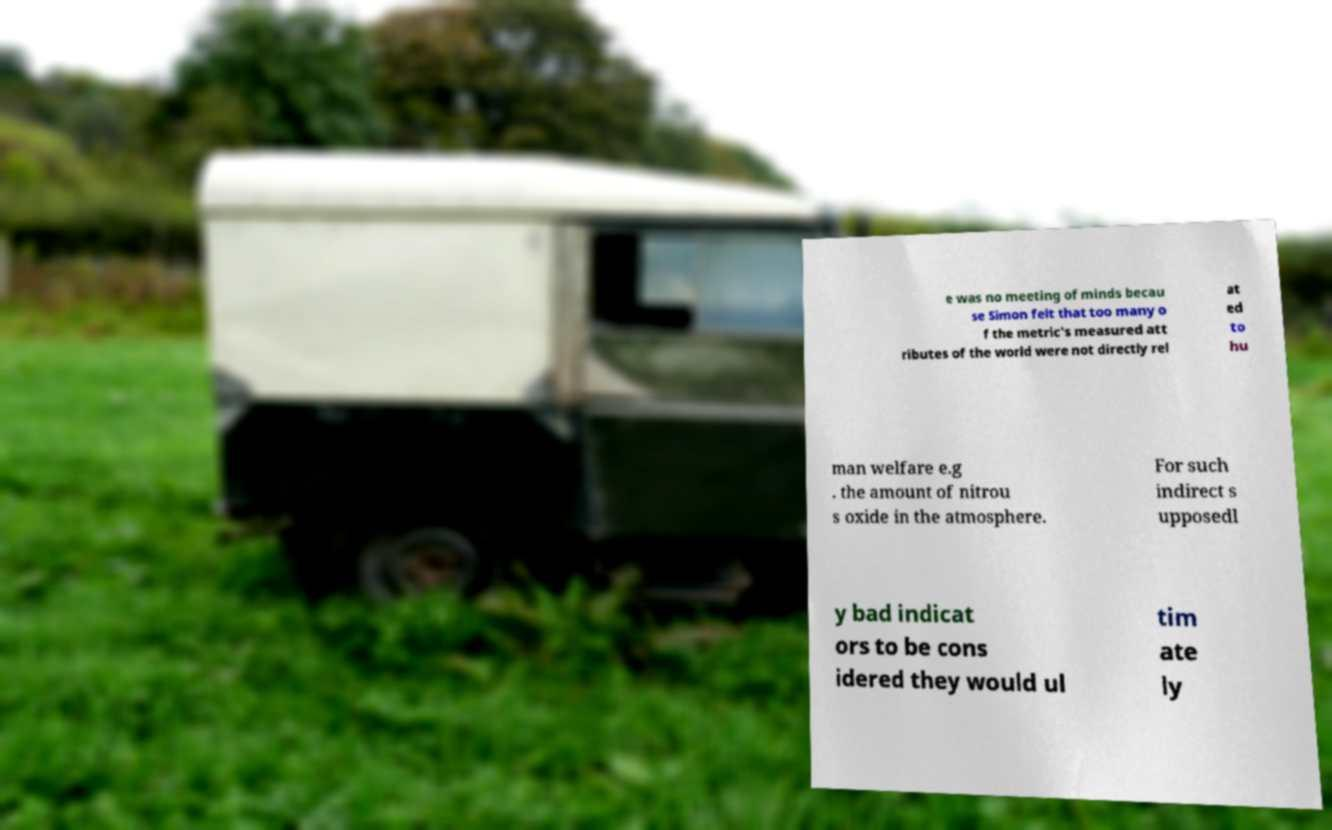Can you read and provide the text displayed in the image?This photo seems to have some interesting text. Can you extract and type it out for me? e was no meeting of minds becau se Simon felt that too many o f the metric's measured att ributes of the world were not directly rel at ed to hu man welfare e.g . the amount of nitrou s oxide in the atmosphere. For such indirect s upposedl y bad indicat ors to be cons idered they would ul tim ate ly 